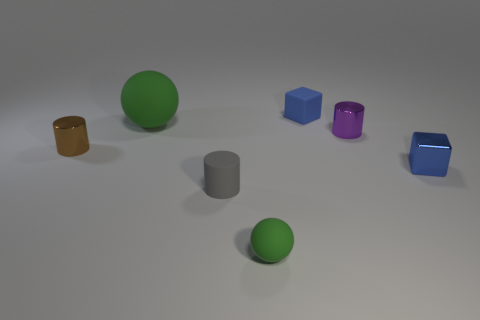Are there any other things that have the same color as the small ball?
Your answer should be very brief. Yes. What size is the green matte thing left of the tiny green matte thing?
Offer a terse response. Large. What is the size of the rubber thing that is both behind the gray object and in front of the tiny blue rubber thing?
Ensure brevity in your answer.  Large. What size is the other green ball that is made of the same material as the tiny green ball?
Ensure brevity in your answer.  Large. What size is the cylinder to the left of the ball behind the tiny cylinder that is in front of the metal block?
Provide a succinct answer. Small. What color is the block left of the small purple metallic cylinder?
Your response must be concise. Blue. Is the number of tiny blue blocks in front of the small purple cylinder greater than the number of cyan metal spheres?
Your answer should be very brief. Yes. Do the tiny blue thing that is to the right of the small purple cylinder and the gray rubber object have the same shape?
Provide a succinct answer. No. What number of cyan things are matte objects or small spheres?
Make the answer very short. 0. Are there more rubber things than small rubber blocks?
Ensure brevity in your answer.  Yes. 